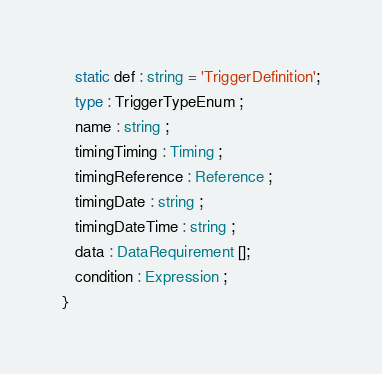Convert code to text. <code><loc_0><loc_0><loc_500><loc_500><_TypeScript_>
   static def : string = 'TriggerDefinition';
   type : TriggerTypeEnum ;
   name : string ;
   timingTiming : Timing ;
   timingReference : Reference ;
   timingDate : string ;
   timingDateTime : string ;
   data : DataRequirement [];
   condition : Expression ;
}
</code> 